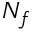Convert formula to latex. <formula><loc_0><loc_0><loc_500><loc_500>N _ { f }</formula> 